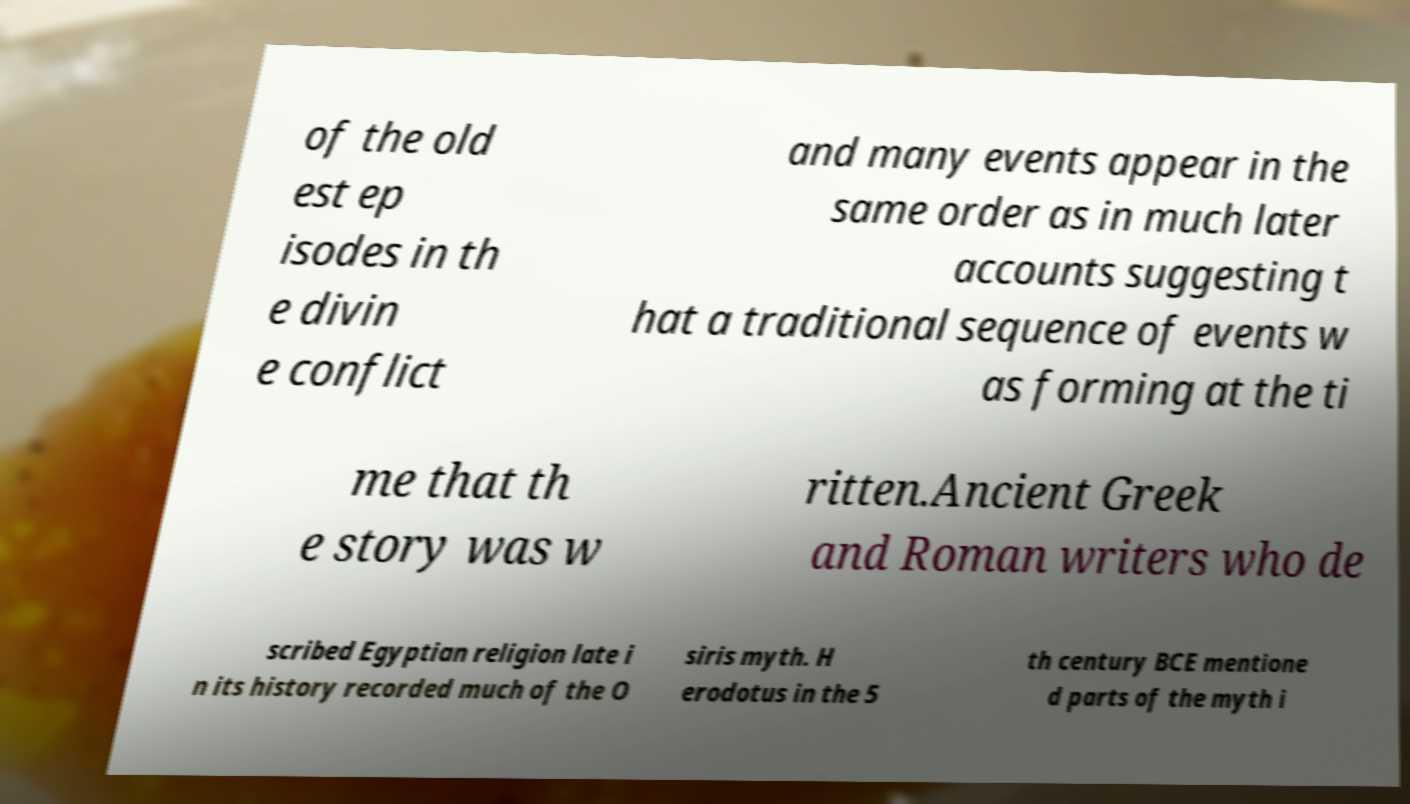There's text embedded in this image that I need extracted. Can you transcribe it verbatim? of the old est ep isodes in th e divin e conflict and many events appear in the same order as in much later accounts suggesting t hat a traditional sequence of events w as forming at the ti me that th e story was w ritten.Ancient Greek and Roman writers who de scribed Egyptian religion late i n its history recorded much of the O siris myth. H erodotus in the 5 th century BCE mentione d parts of the myth i 